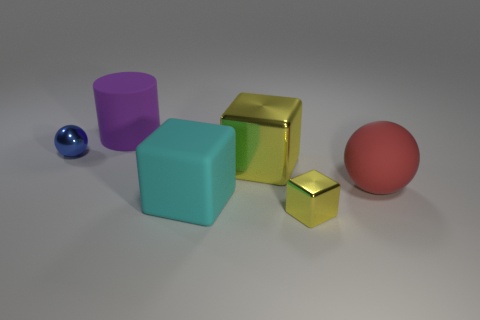How many yellow cubes must be subtracted to get 1 yellow cubes? 1 Add 4 metallic objects. How many objects exist? 10 Subtract all balls. How many objects are left? 4 Add 5 yellow cubes. How many yellow cubes are left? 7 Add 5 small yellow metal cubes. How many small yellow metal cubes exist? 6 Subtract 1 red balls. How many objects are left? 5 Subtract all large rubber cylinders. Subtract all cyan objects. How many objects are left? 4 